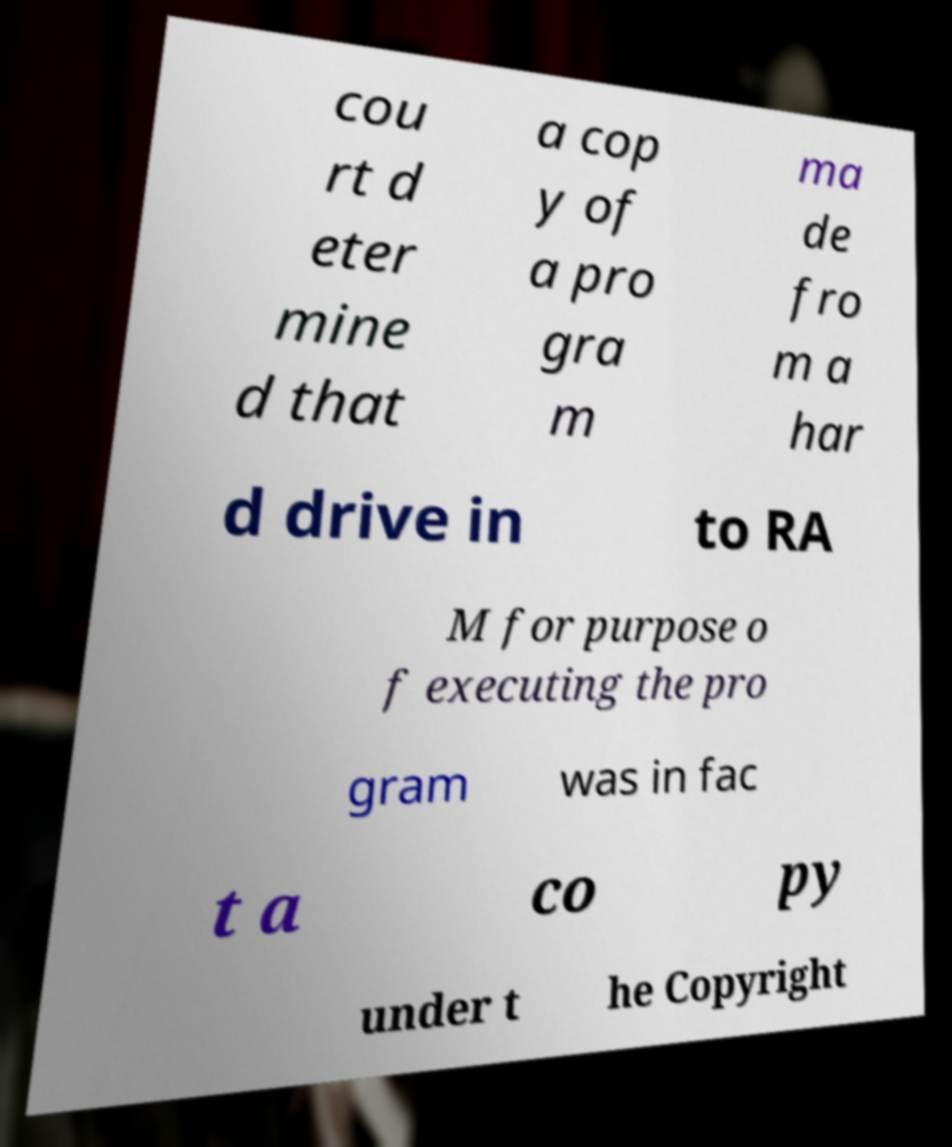I need the written content from this picture converted into text. Can you do that? cou rt d eter mine d that a cop y of a pro gra m ma de fro m a har d drive in to RA M for purpose o f executing the pro gram was in fac t a co py under t he Copyright 